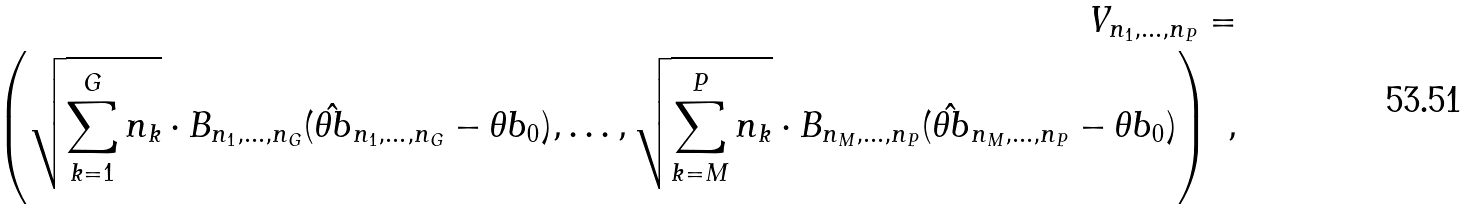Convert formula to latex. <formula><loc_0><loc_0><loc_500><loc_500>V _ { n _ { 1 } , \dots , n _ { P } } = \\ \left ( \sqrt { \sum _ { k = 1 } ^ { G } n _ { k } } \cdot B _ { n _ { 1 } , \dots , n _ { G } } ( \hat { \theta b } _ { n _ { 1 } , \dots , n _ { G } } - \theta b _ { 0 } ) , \dots , \sqrt { \sum _ { k = M } ^ { P } n _ { k } } \cdot B _ { n _ { M } , \dots , n _ { P } } ( \hat { \theta b } _ { n _ { M } , \dots , n _ { P } } - \theta b _ { 0 } ) \right ) \ ,</formula> 